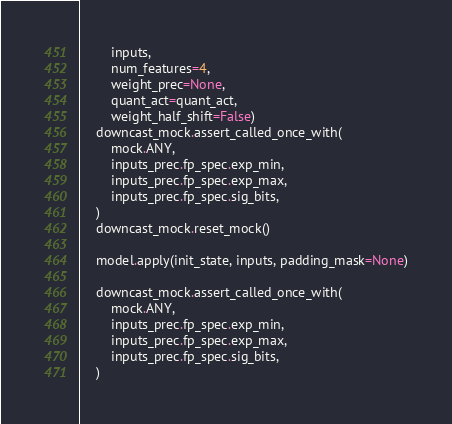<code> <loc_0><loc_0><loc_500><loc_500><_Python_>        inputs,
        num_features=4,
        weight_prec=None,
        quant_act=quant_act,
        weight_half_shift=False)
    downcast_mock.assert_called_once_with(
        mock.ANY,
        inputs_prec.fp_spec.exp_min,
        inputs_prec.fp_spec.exp_max,
        inputs_prec.fp_spec.sig_bits,
    )
    downcast_mock.reset_mock()

    model.apply(init_state, inputs, padding_mask=None)

    downcast_mock.assert_called_once_with(
        mock.ANY,
        inputs_prec.fp_spec.exp_min,
        inputs_prec.fp_spec.exp_max,
        inputs_prec.fp_spec.sig_bits,
    )
</code> 